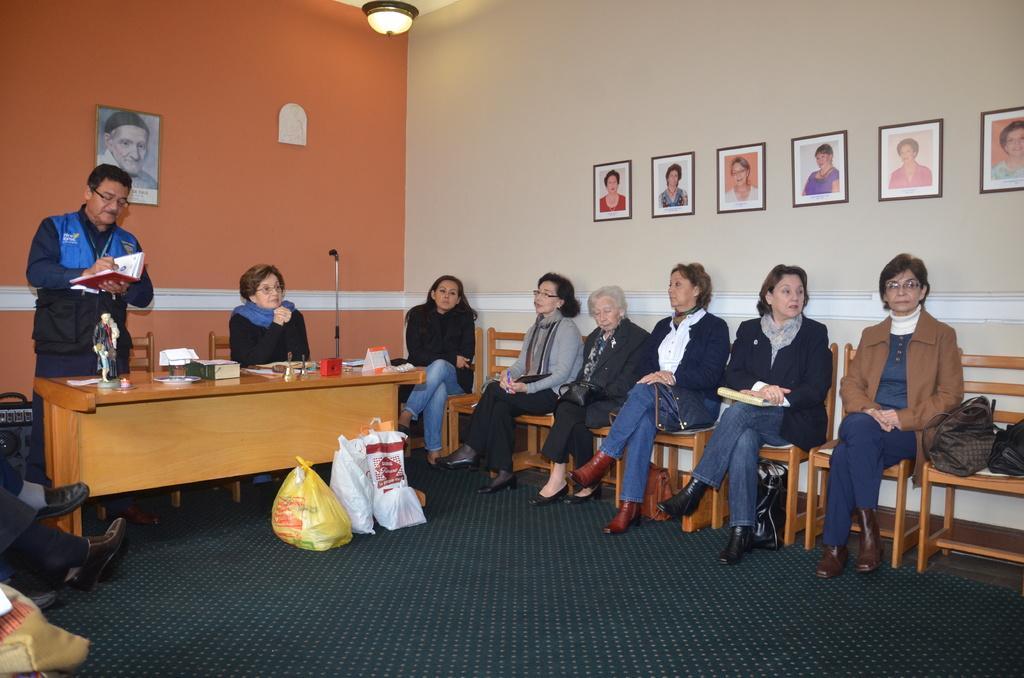How would you summarize this image in a sentence or two? In this image we have group of people who are sitting on the chair and on the left side of the image we have a man who is standing on the floor and holding a book in his hands and writing with pen, behind this man we have red color wall with wall photo on it, on the floor we have a few bags. 